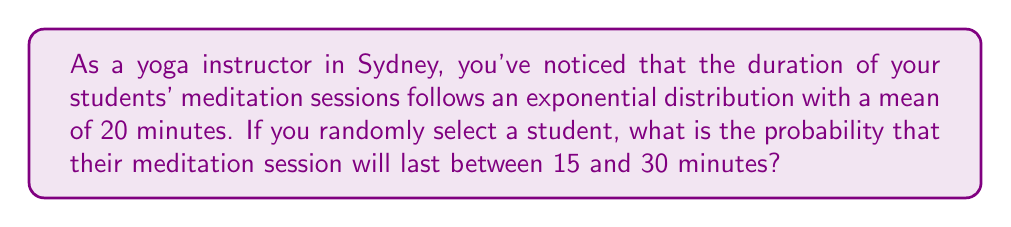Could you help me with this problem? Let's approach this step-by-step:

1) The exponential distribution has a probability density function:
   $$f(x) = \lambda e^{-\lambda x}$$
   where $\lambda$ is the rate parameter.

2) Given that the mean of an exponential distribution is $\frac{1}{\lambda}$, we can find $\lambda$:
   $$\frac{1}{\lambda} = 20$$
   $$\lambda = \frac{1}{20} = 0.05$$

3) The probability of a meditation session lasting between 15 and 30 minutes is:
   $$P(15 < X < 30) = \int_{15}^{30} 0.05e^{-0.05x} dx$$

4) To solve this, we can use the cumulative distribution function (CDF) of the exponential distribution:
   $$F(x) = 1 - e^{-\lambda x}$$

5) Therefore:
   $$P(15 < X < 30) = F(30) - F(15)$$
   $$= (1 - e^{-0.05 * 30}) - (1 - e^{-0.05 * 15})$$
   $$= e^{-0.05 * 15} - e^{-0.05 * 30}$$

6) Calculating:
   $$= e^{-0.75} - e^{-1.5}$$
   $$\approx 0.4724 - 0.2231$$
   $$\approx 0.2493$$

Therefore, the probability is approximately 0.2493 or about 24.93%.
Answer: 0.2493 